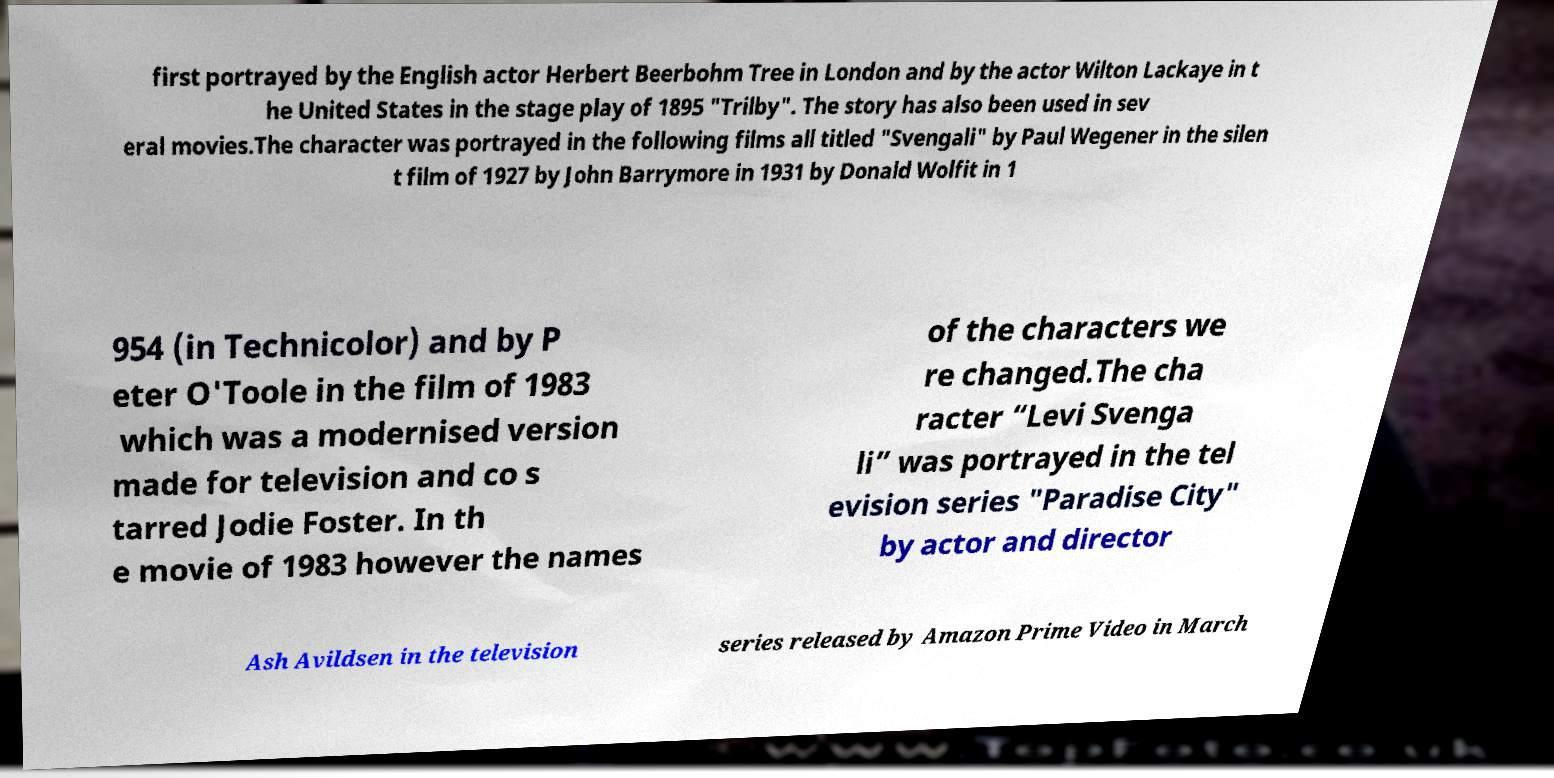Can you accurately transcribe the text from the provided image for me? first portrayed by the English actor Herbert Beerbohm Tree in London and by the actor Wilton Lackaye in t he United States in the stage play of 1895 "Trilby". The story has also been used in sev eral movies.The character was portrayed in the following films all titled "Svengali" by Paul Wegener in the silen t film of 1927 by John Barrymore in 1931 by Donald Wolfit in 1 954 (in Technicolor) and by P eter O'Toole in the film of 1983 which was a modernised version made for television and co s tarred Jodie Foster. In th e movie of 1983 however the names of the characters we re changed.The cha racter “Levi Svenga li” was portrayed in the tel evision series "Paradise City" by actor and director Ash Avildsen in the television series released by Amazon Prime Video in March 